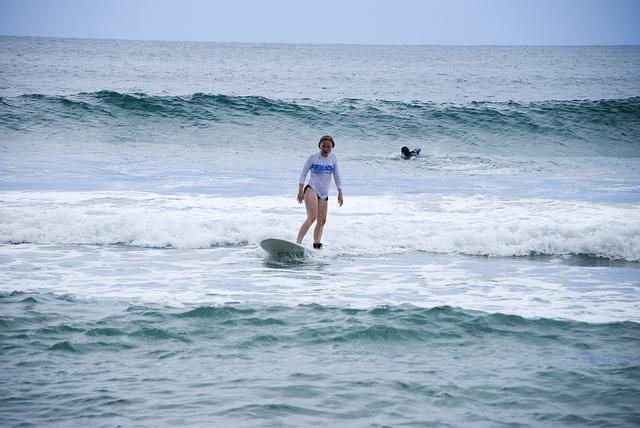How many people are in the water?
Give a very brief answer. 2. How many surfers are present?
Give a very brief answer. 2. 